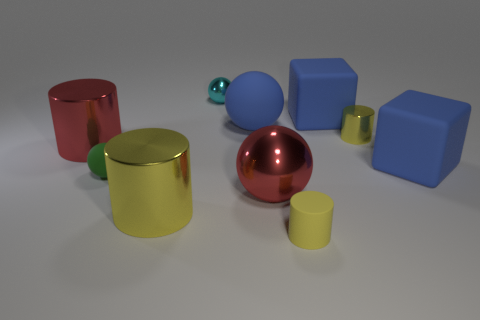The green object that is the same material as the blue ball is what shape?
Your answer should be very brief. Sphere. Is there any other thing that has the same color as the tiny shiny cylinder?
Provide a succinct answer. Yes. What number of green things are there?
Make the answer very short. 1. What is the tiny cylinder that is on the right side of the tiny rubber object right of the small cyan object made of?
Provide a succinct answer. Metal. What is the color of the small object that is in front of the red thing in front of the tiny green ball that is in front of the tiny cyan shiny object?
Your response must be concise. Yellow. Do the tiny matte cylinder and the small metal cylinder have the same color?
Provide a succinct answer. Yes. How many things are the same size as the green ball?
Provide a short and direct response. 3. Is the number of tiny green rubber objects that are left of the tiny cyan metal sphere greater than the number of blue cubes that are to the right of the tiny yellow shiny thing?
Provide a succinct answer. No. The rubber sphere that is in front of the tiny yellow cylinder behind the large red metal ball is what color?
Offer a very short reply. Green. Is the material of the tiny cyan object the same as the big yellow cylinder?
Offer a very short reply. Yes. 